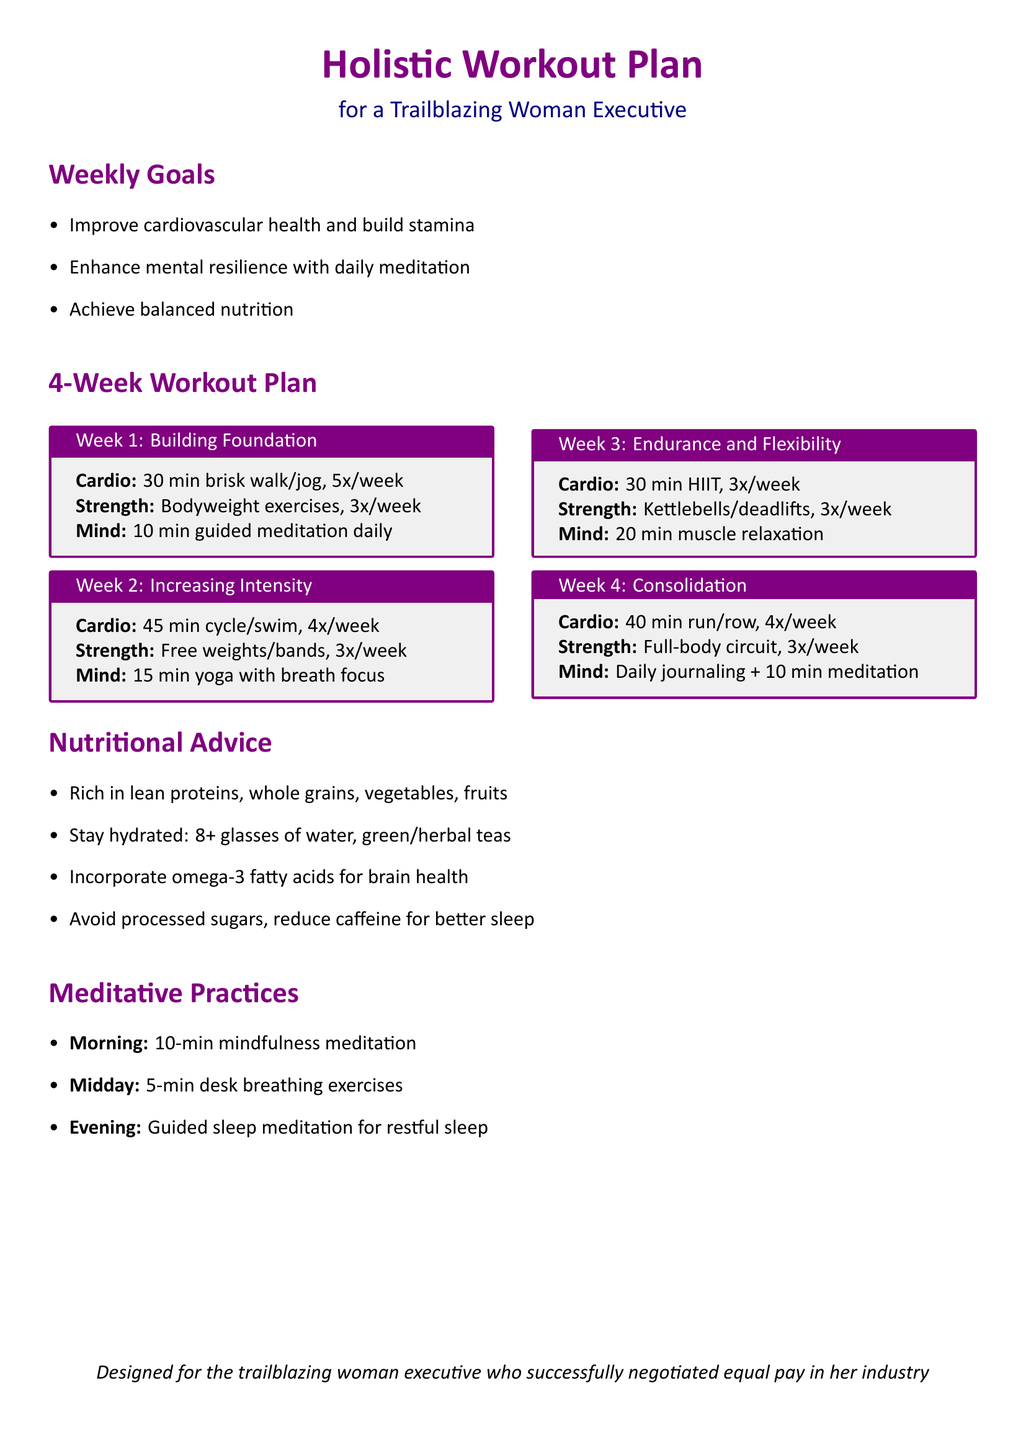What is the title of the workout plan? The title is stated in the document as "Holistic Workout Plan."
Answer: Holistic Workout Plan How many weeks does the workout plan cover? It explicitly states that it is a "4-Week Workout Plan."
Answer: 4 What is the focus of the meditation practice in Week 1? The meditation practice involves "10 min guided meditation daily."
Answer: 10 min guided meditation daily What type of exercises are included in Week 3 for strength training? Week 3 includes "Kettlebells/deadlifts" for strength training.
Answer: Kettlebells/deadlifts How many days a week is cardiovascular exercise recommended in Week 2? The plan specifies "4x/week" for the cardio exercise in Week 2.
Answer: 4x/week What nutritional element is recommended for brain health? The document advises to "Incorporate omega-3 fatty acids for brain health."
Answer: omega-3 fatty acids Which day is specified for guided sleep meditation? The evening is specified for "Guided sleep meditation for restful sleep."
Answer: Evening What exercise type is advised in Week 4 for endurance? Week 4 recommends "40 min run/row" for endurance.
Answer: 40 min run/row 